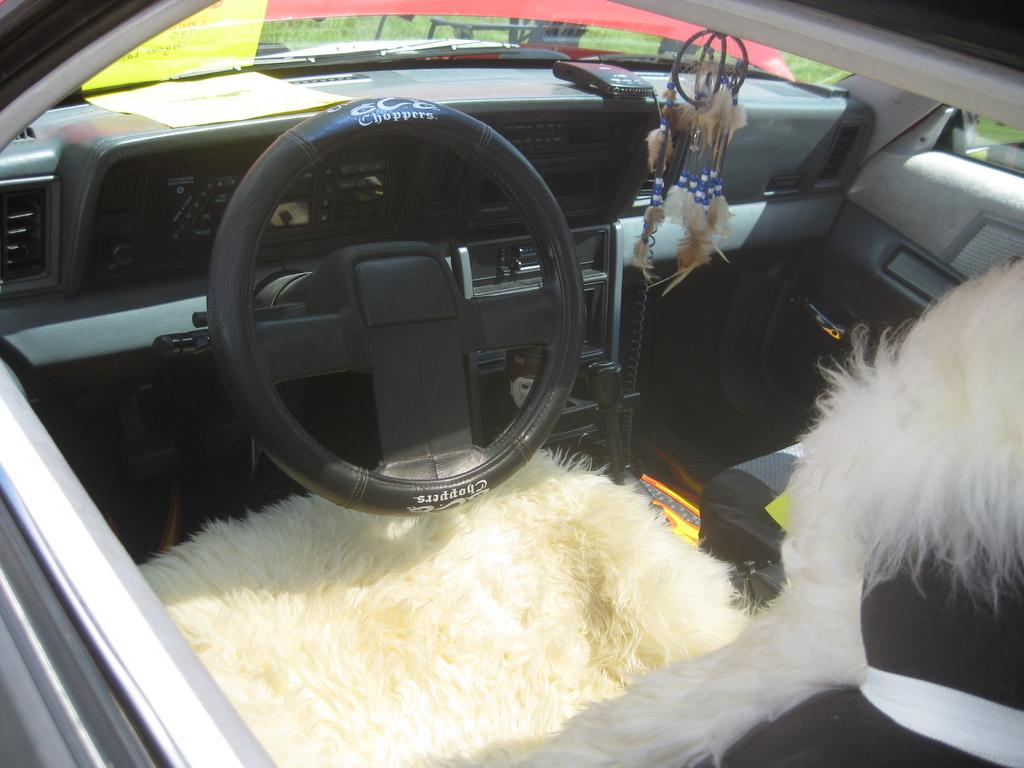What type of vehicle is shown in the image? The image shows the inside view of a car. What is used to control the direction of the car? There is a steering wheel in the car. How can the driver change gears in the car? A hand gear is present in the car. What is provided for passengers to sit in the car? There are seats in the car. What device is used to monitor the car's performance? An auto gauge is visible in the car. What is the main control panel in the car? There is a dashboard in the car. How does one enter or exit the car? The car has doors. How many times does the crack in the windshield appear in the image? There is no crack in the windshield visible in the image. What type of pump is used to inflate the tires in the image? There is no pump present in the image; it only shows the interior of the car. 